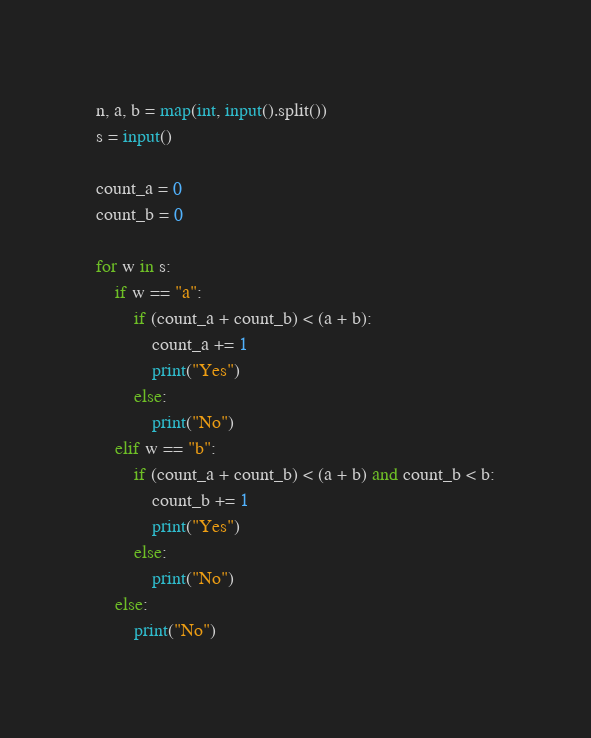Convert code to text. <code><loc_0><loc_0><loc_500><loc_500><_Python_>n, a, b = map(int, input().split())
s = input()

count_a = 0
count_b = 0

for w in s:
    if w == "a":
        if (count_a + count_b) < (a + b):
            count_a += 1
            print("Yes")
        else:
            print("No")
    elif w == "b":
        if (count_a + count_b) < (a + b) and count_b < b:
            count_b += 1
            print("Yes")
        else:
            print("No")
    else:
        print("No")
</code> 